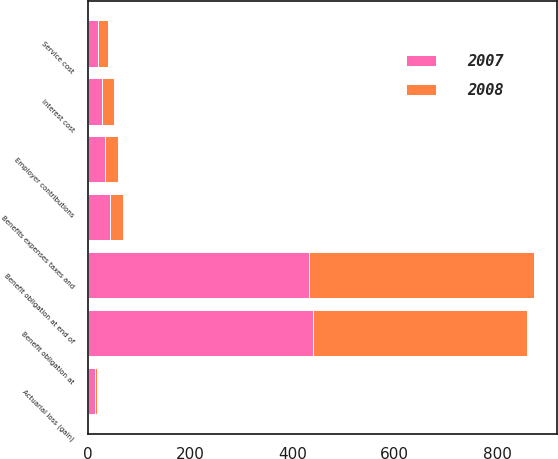Convert chart to OTSL. <chart><loc_0><loc_0><loc_500><loc_500><stacked_bar_chart><ecel><fcel>Benefit obligation at<fcel>Service cost<fcel>Interest cost<fcel>Actuarial loss (gain)<fcel>Benefits expenses taxes and<fcel>Benefit obligation at end of<fcel>Employer contributions<nl><fcel>2007<fcel>440.5<fcel>19.7<fcel>26.2<fcel>13.1<fcel>42.8<fcel>432.6<fcel>32.7<nl><fcel>2008<fcel>417.5<fcel>18.4<fcel>25<fcel>4.4<fcel>24.8<fcel>440.5<fcel>25.3<nl></chart> 